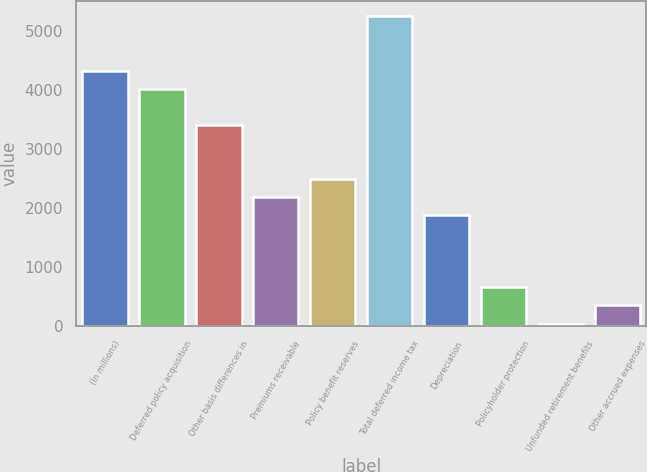Convert chart. <chart><loc_0><loc_0><loc_500><loc_500><bar_chart><fcel>(In millions)<fcel>Deferred policy acquisition<fcel>Other basis differences in<fcel>Premiums receivable<fcel>Policy benefit reserves<fcel>Total deferred income tax<fcel>Depreciation<fcel>Policyholder protection<fcel>Unfunded retirement benefits<fcel>Other accrued expenses<nl><fcel>4327<fcel>4021<fcel>3409<fcel>2185<fcel>2491<fcel>5245<fcel>1879<fcel>655<fcel>43<fcel>349<nl></chart> 